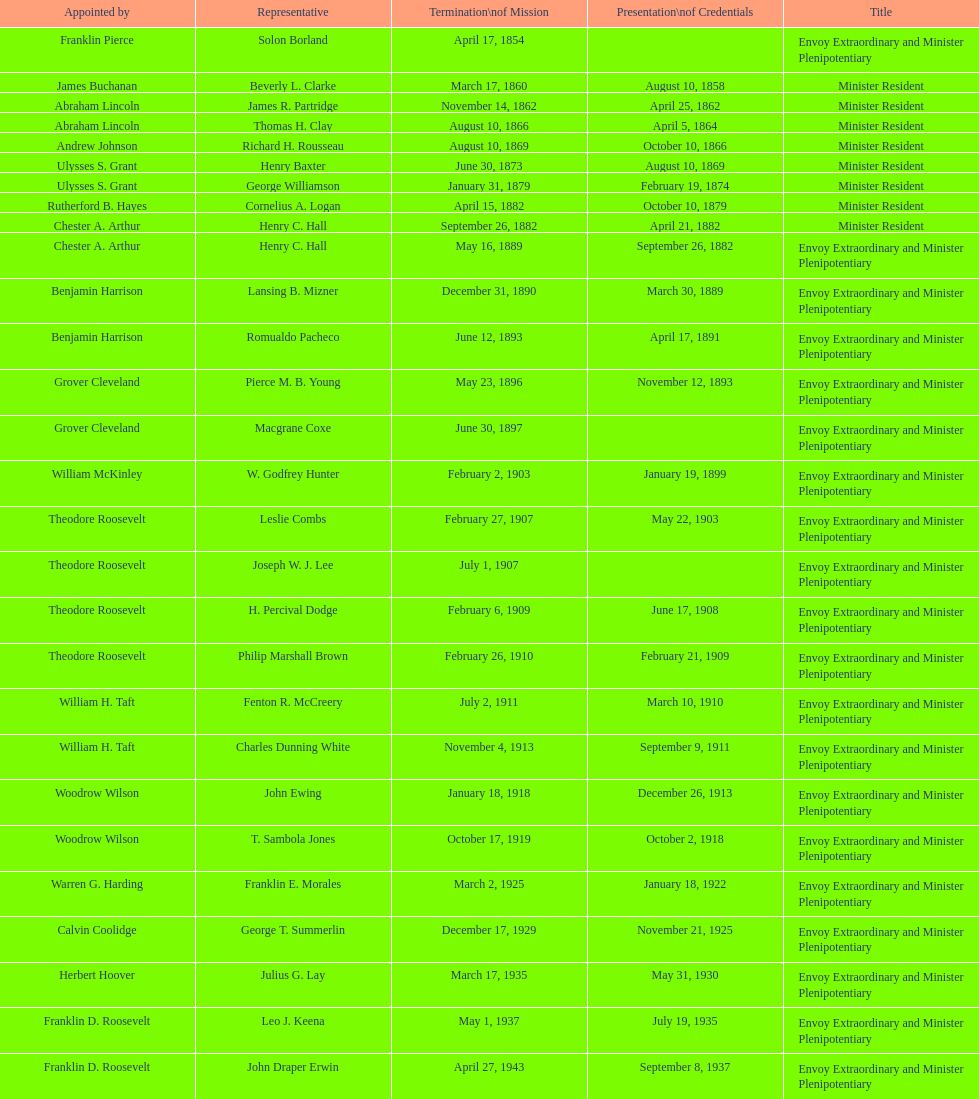Could you help me parse every detail presented in this table? {'header': ['Appointed by', 'Representative', 'Termination\\nof Mission', 'Presentation\\nof Credentials', 'Title'], 'rows': [['Franklin Pierce', 'Solon Borland', 'April 17, 1854', '', 'Envoy Extraordinary and Minister Plenipotentiary'], ['James Buchanan', 'Beverly L. Clarke', 'March 17, 1860', 'August 10, 1858', 'Minister Resident'], ['Abraham Lincoln', 'James R. Partridge', 'November 14, 1862', 'April 25, 1862', 'Minister Resident'], ['Abraham Lincoln', 'Thomas H. Clay', 'August 10, 1866', 'April 5, 1864', 'Minister Resident'], ['Andrew Johnson', 'Richard H. Rousseau', 'August 10, 1869', 'October 10, 1866', 'Minister Resident'], ['Ulysses S. Grant', 'Henry Baxter', 'June 30, 1873', 'August 10, 1869', 'Minister Resident'], ['Ulysses S. Grant', 'George Williamson', 'January 31, 1879', 'February 19, 1874', 'Minister Resident'], ['Rutherford B. Hayes', 'Cornelius A. Logan', 'April 15, 1882', 'October 10, 1879', 'Minister Resident'], ['Chester A. Arthur', 'Henry C. Hall', 'September 26, 1882', 'April 21, 1882', 'Minister Resident'], ['Chester A. Arthur', 'Henry C. Hall', 'May 16, 1889', 'September 26, 1882', 'Envoy Extraordinary and Minister Plenipotentiary'], ['Benjamin Harrison', 'Lansing B. Mizner', 'December 31, 1890', 'March 30, 1889', 'Envoy Extraordinary and Minister Plenipotentiary'], ['Benjamin Harrison', 'Romualdo Pacheco', 'June 12, 1893', 'April 17, 1891', 'Envoy Extraordinary and Minister Plenipotentiary'], ['Grover Cleveland', 'Pierce M. B. Young', 'May 23, 1896', 'November 12, 1893', 'Envoy Extraordinary and Minister Plenipotentiary'], ['Grover Cleveland', 'Macgrane Coxe', 'June 30, 1897', '', 'Envoy Extraordinary and Minister Plenipotentiary'], ['William McKinley', 'W. Godfrey Hunter', 'February 2, 1903', 'January 19, 1899', 'Envoy Extraordinary and Minister Plenipotentiary'], ['Theodore Roosevelt', 'Leslie Combs', 'February 27, 1907', 'May 22, 1903', 'Envoy Extraordinary and Minister Plenipotentiary'], ['Theodore Roosevelt', 'Joseph W. J. Lee', 'July 1, 1907', '', 'Envoy Extraordinary and Minister Plenipotentiary'], ['Theodore Roosevelt', 'H. Percival Dodge', 'February 6, 1909', 'June 17, 1908', 'Envoy Extraordinary and Minister Plenipotentiary'], ['Theodore Roosevelt', 'Philip Marshall Brown', 'February 26, 1910', 'February 21, 1909', 'Envoy Extraordinary and Minister Plenipotentiary'], ['William H. Taft', 'Fenton R. McCreery', 'July 2, 1911', 'March 10, 1910', 'Envoy Extraordinary and Minister Plenipotentiary'], ['William H. Taft', 'Charles Dunning White', 'November 4, 1913', 'September 9, 1911', 'Envoy Extraordinary and Minister Plenipotentiary'], ['Woodrow Wilson', 'John Ewing', 'January 18, 1918', 'December 26, 1913', 'Envoy Extraordinary and Minister Plenipotentiary'], ['Woodrow Wilson', 'T. Sambola Jones', 'October 17, 1919', 'October 2, 1918', 'Envoy Extraordinary and Minister Plenipotentiary'], ['Warren G. Harding', 'Franklin E. Morales', 'March 2, 1925', 'January 18, 1922', 'Envoy Extraordinary and Minister Plenipotentiary'], ['Calvin Coolidge', 'George T. Summerlin', 'December 17, 1929', 'November 21, 1925', 'Envoy Extraordinary and Minister Plenipotentiary'], ['Herbert Hoover', 'Julius G. Lay', 'March 17, 1935', 'May 31, 1930', 'Envoy Extraordinary and Minister Plenipotentiary'], ['Franklin D. Roosevelt', 'Leo J. Keena', 'May 1, 1937', 'July 19, 1935', 'Envoy Extraordinary and Minister Plenipotentiary'], ['Franklin D. Roosevelt', 'John Draper Erwin', 'April 27, 1943', 'September 8, 1937', 'Envoy Extraordinary and Minister Plenipotentiary'], ['Franklin D. Roosevelt', 'John Draper Erwin', 'April 16, 1947', 'April 27, 1943', 'Ambassador Extraordinary and Plenipotentiary'], ['Harry S. Truman', 'Paul C. Daniels', 'October 30, 1947', 'June 23, 1947', 'Ambassador Extraordinary and Plenipotentiary'], ['Harry S. Truman', 'Herbert S. Bursley', 'December 12, 1950', 'May 15, 1948', 'Ambassador Extraordinary and Plenipotentiary'], ['Harry S. Truman', 'John Draper Erwin', 'February 28, 1954', 'March 14, 1951', 'Ambassador Extraordinary and Plenipotentiary'], ['Dwight D. Eisenhower', 'Whiting Willauer', 'March 24, 1958', 'March 5, 1954', 'Ambassador Extraordinary and Plenipotentiary'], ['Dwight D. Eisenhower', 'Robert Newbegin', 'August 3, 1960', 'April 30, 1958', 'Ambassador Extraordinary and Plenipotentiary'], ['Dwight D. Eisenhower', 'Charles R. Burrows', 'June 28, 1965', 'November 3, 1960', 'Ambassador Extraordinary and Plenipotentiary'], ['Lyndon B. Johnson', 'Joseph J. Jova', 'June 21, 1969', 'July 12, 1965', 'Ambassador Extraordinary and Plenipotentiary'], ['Richard Nixon', 'Hewson A. Ryan', 'May 30, 1973', 'November 5, 1969', 'Ambassador Extraordinary and Plenipotentiary'], ['Richard Nixon', 'Phillip V. Sanchez', 'July 17, 1976', 'June 15, 1973', 'Ambassador Extraordinary and Plenipotentiary'], ['Gerald Ford', 'Ralph E. Becker', 'August 1, 1977', 'October 27, 1976', 'Ambassador Extraordinary and Plenipotentiary'], ['Jimmy Carter', 'Mari-Luci Jaramillo', 'September 19, 1980', 'October 27, 1977', 'Ambassador Extraordinary and Plenipotentiary'], ['Jimmy Carter', 'Jack R. Binns', 'October 31, 1981', 'October 10, 1980', 'Ambassador Extraordinary and Plenipotentiary'], ['Ronald Reagan', 'John D. Negroponte', 'May 30, 1985', 'November 11, 1981', 'Ambassador Extraordinary and Plenipotentiary'], ['Ronald Reagan', 'John Arthur Ferch', 'July 9, 1986', 'August 22, 1985', 'Ambassador Extraordinary and Plenipotentiary'], ['Ronald Reagan', 'Everett Ellis Briggs', 'June 15, 1989', 'November 4, 1986', 'Ambassador Extraordinary and Plenipotentiary'], ['George H. W. Bush', 'Cresencio S. Arcos, Jr.', 'July 1, 1993', 'January 29, 1990', 'Ambassador Extraordinary and Plenipotentiary'], ['Bill Clinton', 'William Thornton Pryce', 'August 15, 1996', 'July 21, 1993', 'Ambassador Extraordinary and Plenipotentiary'], ['Bill Clinton', 'James F. Creagan', 'July 20, 1999', 'August 29, 1996', 'Ambassador Extraordinary and Plenipotentiary'], ['Bill Clinton', 'Frank Almaguer', 'September 5, 2002', 'August 25, 1999', 'Ambassador Extraordinary and Plenipotentiary'], ['George W. Bush', 'Larry Leon Palmer', 'May 7, 2005', 'October 8, 2002', 'Ambassador Extraordinary and Plenipotentiary'], ['George W. Bush', 'Charles A. Ford', 'ca. April 2008', 'November 8, 2005', 'Ambassador Extraordinary and Plenipotentiary'], ['George W. Bush', 'Hugo Llorens', 'ca. July 2011', 'September 19, 2008', 'Ambassador Extraordinary and Plenipotentiary'], ['Barack Obama', 'Lisa Kubiske', 'Incumbent', 'July 26, 2011', 'Ambassador Extraordinary and Plenipotentiary']]} Who was the last representative picked? Lisa Kubiske. 